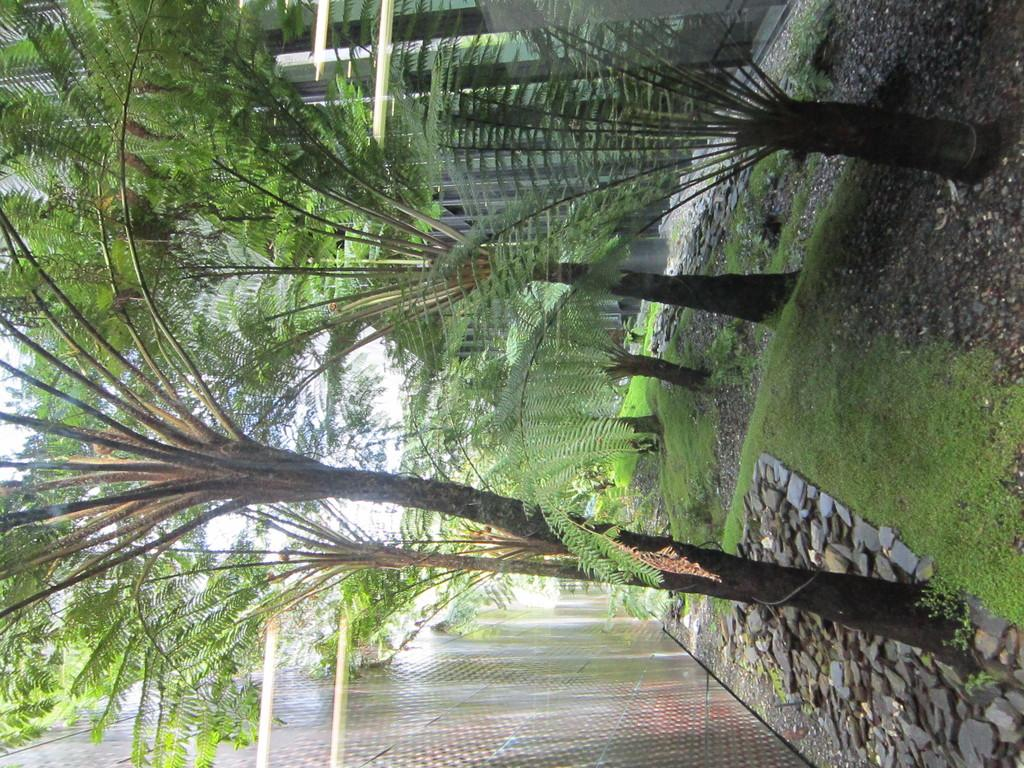What type of vegetation can be seen in the image? There are trees in the image. What is located beside the trees in the image? There is a wall beside the trees in the image. What type of fruit is hanging from the trees in the image? There is no fruit hanging from the trees in the image. What form does the wall beside the trees take in the image? The wall is a solid, vertical structure beside the trees in the image. 